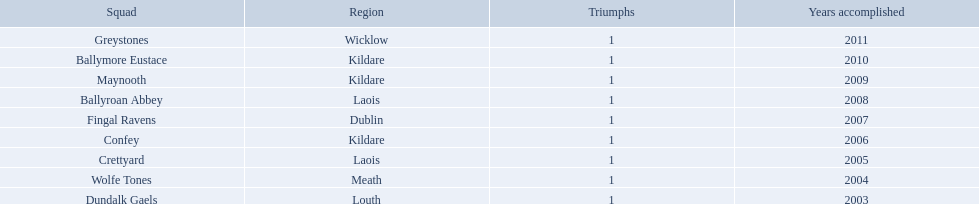Which is the first team from the chart Greystones. 